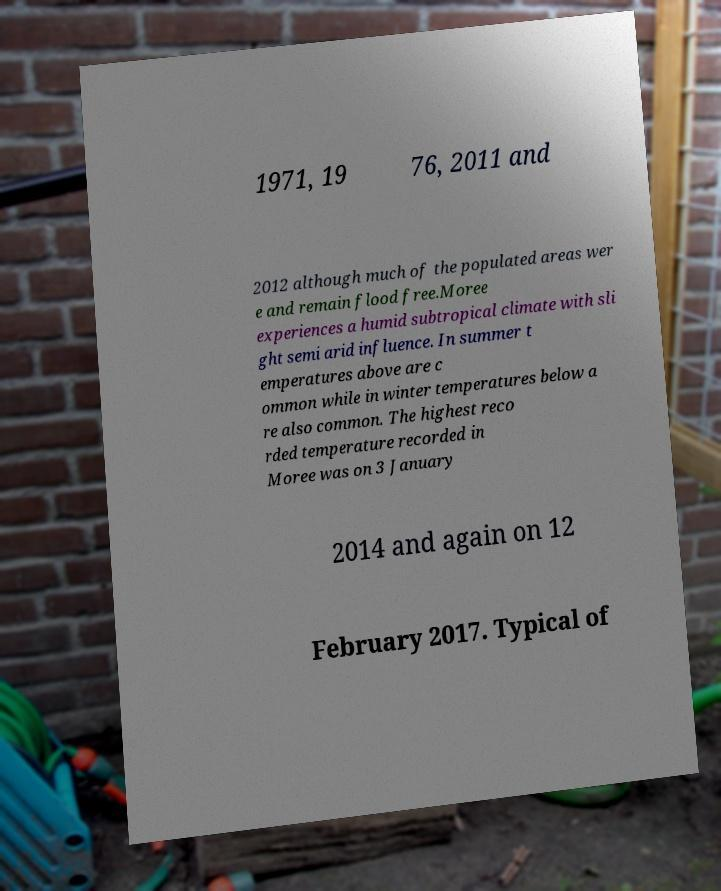Can you read and provide the text displayed in the image?This photo seems to have some interesting text. Can you extract and type it out for me? 1971, 19 76, 2011 and 2012 although much of the populated areas wer e and remain flood free.Moree experiences a humid subtropical climate with sli ght semi arid influence. In summer t emperatures above are c ommon while in winter temperatures below a re also common. The highest reco rded temperature recorded in Moree was on 3 January 2014 and again on 12 February 2017. Typical of 